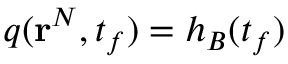<formula> <loc_0><loc_0><loc_500><loc_500>q ( r ^ { N } , t _ { f } ) = h _ { B } ( t _ { f } )</formula> 